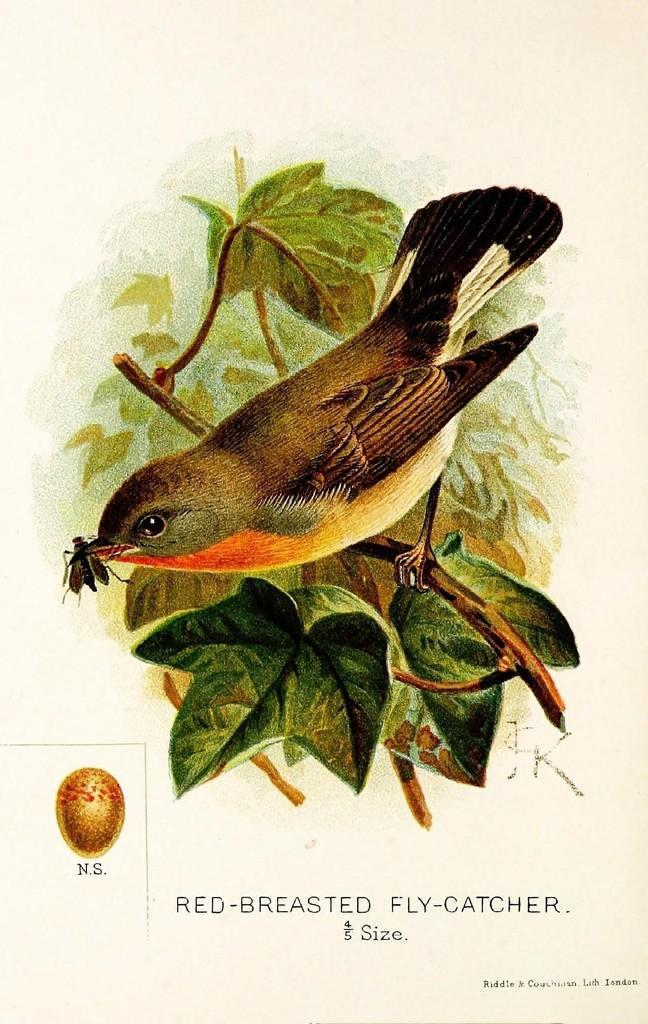What is depicted in the painting in the image? There is a painting of a bird in the image. Where is the bird located in the painting? The bird is on a tree in the painting. What else can be seen in the image besides the painting? There is text and a logo in the image. What type of jewel is the bird holding in the image? There is no jewel present in the image; the bird is depicted on a tree in the painting. 